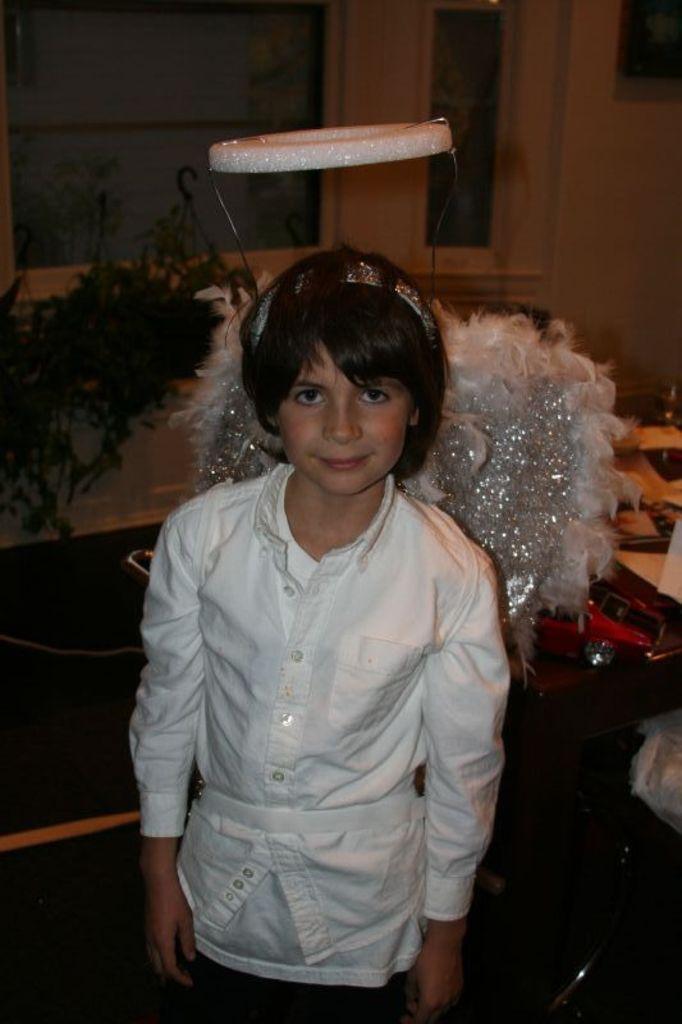How would you summarize this image in a sentence or two? In this picture we can see a girl, she is smiling, in the background we can see a plant and a toy. 